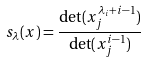<formula> <loc_0><loc_0><loc_500><loc_500>s _ { \lambda } ( x ) = \frac { \det ( x _ { j } ^ { \lambda _ { i } + i - 1 } ) } { \det ( x _ { j } ^ { i - 1 } ) }</formula> 